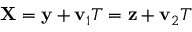<formula> <loc_0><loc_0><loc_500><loc_500>{ X } = { y } + { v } _ { 1 } T = { z } + { v } _ { 2 } T</formula> 